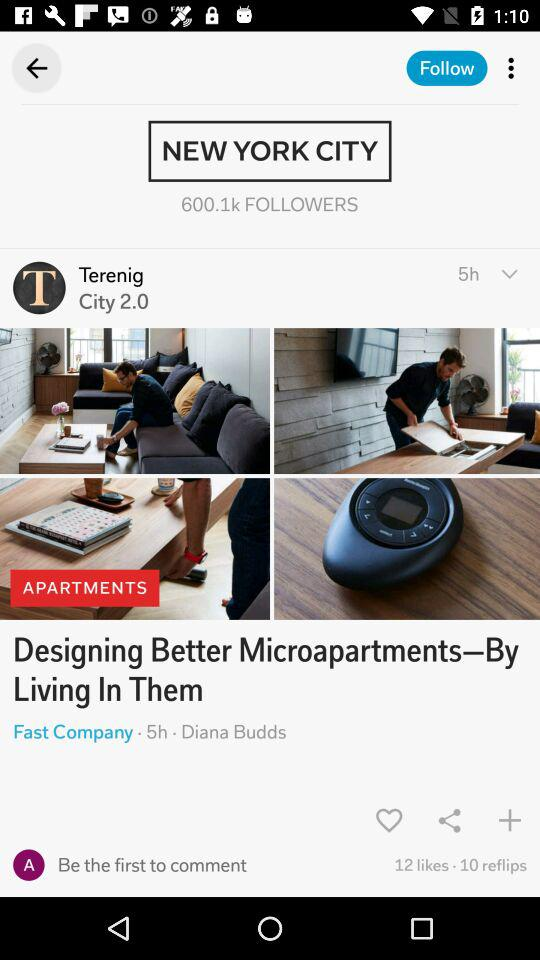How many people liked the post?
Answer the question using a single word or phrase. 12 